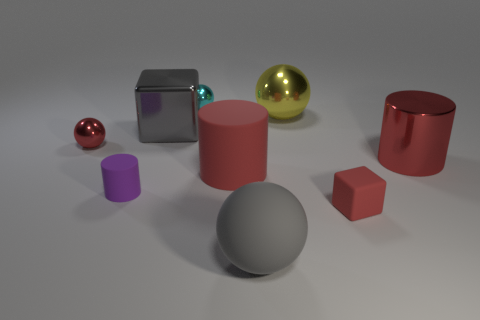There is a rubber cube that is the same color as the metallic cylinder; what is its size?
Your answer should be very brief. Small. Are there any other things of the same color as the big rubber sphere?
Provide a short and direct response. Yes. The sphere in front of the tiny sphere left of the block behind the big red matte cylinder is what color?
Make the answer very short. Gray. What is the size of the block on the right side of the big red thing to the left of the large yellow object?
Your answer should be very brief. Small. The tiny object that is right of the red shiny ball and behind the tiny purple matte cylinder is made of what material?
Offer a terse response. Metal. Is the size of the red shiny sphere the same as the metal sphere that is to the right of the gray ball?
Keep it short and to the point. No. Are there any matte balls?
Make the answer very short. Yes. What is the material of the gray thing that is the same shape as the big yellow thing?
Offer a very short reply. Rubber. There is a cube that is behind the small red thing that is behind the large red matte cylinder that is in front of the large yellow ball; what is its size?
Give a very brief answer. Large. Are there any tiny rubber blocks behind the small purple rubber thing?
Offer a very short reply. No. 